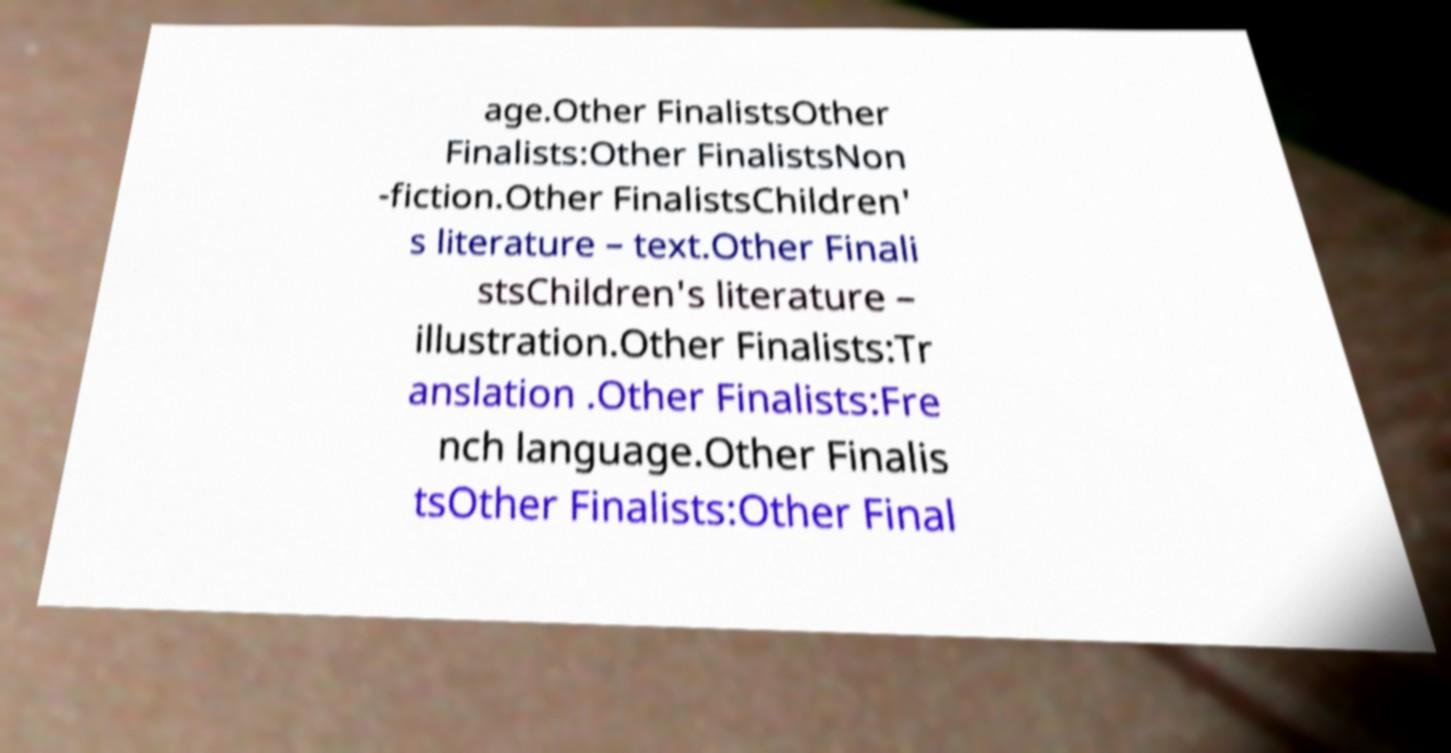Please read and relay the text visible in this image. What does it say? age.Other FinalistsOther Finalists:Other FinalistsNon -fiction.Other FinalistsChildren' s literature – text.Other Finali stsChildren's literature – illustration.Other Finalists:Tr anslation .Other Finalists:Fre nch language.Other Finalis tsOther Finalists:Other Final 